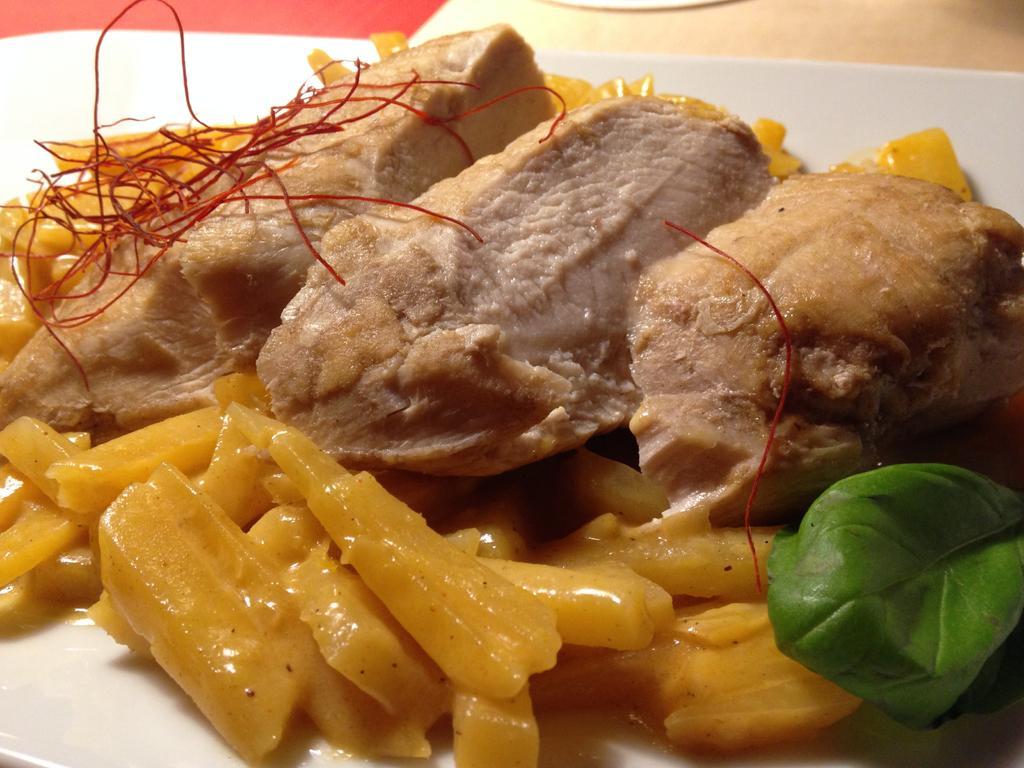How would you summarize this image in a sentence or two? In the center of the image there is a food in plate placed on the table. 